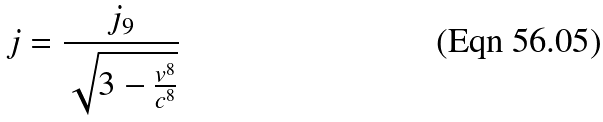<formula> <loc_0><loc_0><loc_500><loc_500>j = \frac { j _ { 9 } } { \sqrt { 3 - \frac { v ^ { 8 } } { c ^ { 8 } } } }</formula> 